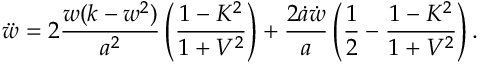<formula> <loc_0><loc_0><loc_500><loc_500>\ddot { w } = 2 \frac { w ( k - w ^ { 2 } ) } { a ^ { 2 } } \left ( \frac { 1 - K ^ { 2 } } { 1 + V ^ { 2 } } \right ) + \frac { 2 \dot { a } \dot { w } } { a } \left ( \frac { 1 } { 2 } - \frac { 1 - K ^ { 2 } } { 1 + V ^ { 2 } } \right ) .</formula> 